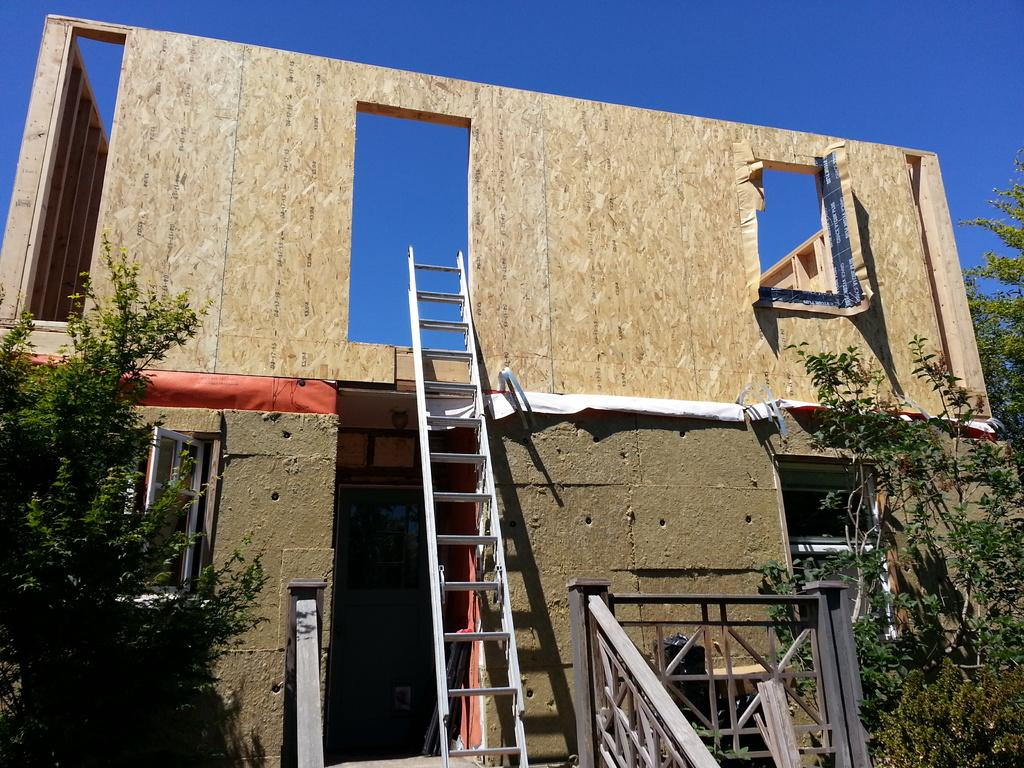What structure is the main focus of the image? There is a building in the image. What object is placed near the building? A ladder is kept near the building. What type of vegetation surrounds the building? There are trees to the left and right of the building. What can be seen in the sky in the image? The sky is visible at the top of the image, and it is blue in color. How many girls are holding needles during the rainstorm in the image? There are no girls or rainstorm present in the image. What type of needle can be seen piercing the building in the image? There is no needle piercing the building in the image. 